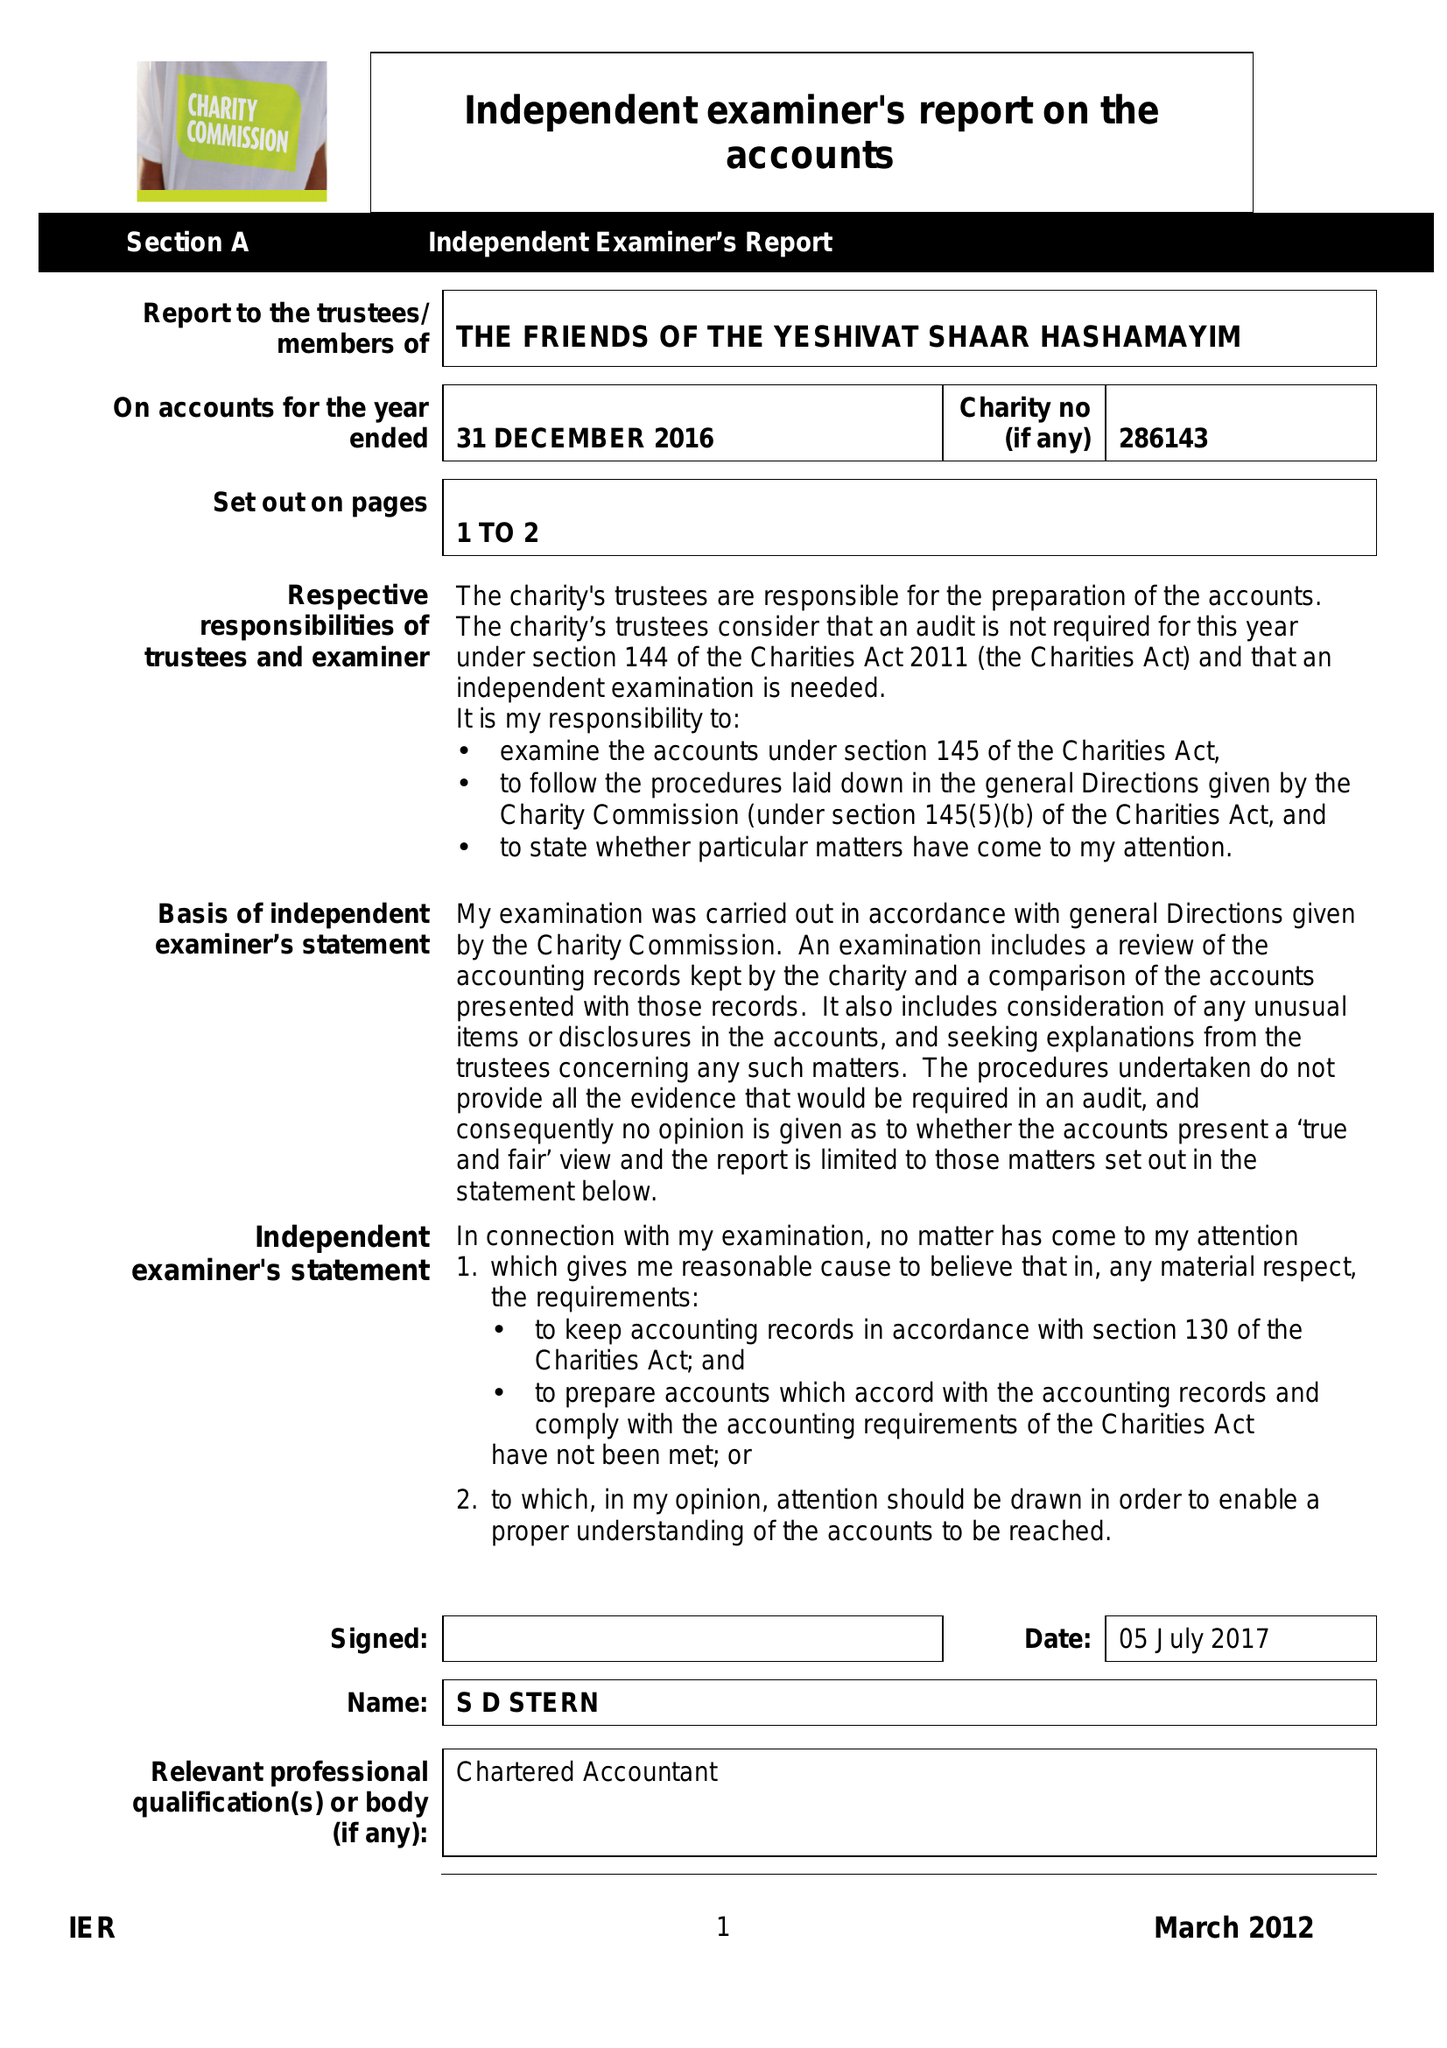What is the value for the report_date?
Answer the question using a single word or phrase. 2016-12-31 